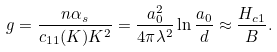<formula> <loc_0><loc_0><loc_500><loc_500>g = \frac { n \alpha _ { s } } { c _ { 1 1 } ( K ) K ^ { 2 } } = \frac { a _ { 0 } ^ { 2 } } { 4 \pi \lambda ^ { 2 } } \ln \frac { a _ { 0 } } { d } \approx \frac { H _ { c 1 } } { B } .</formula> 